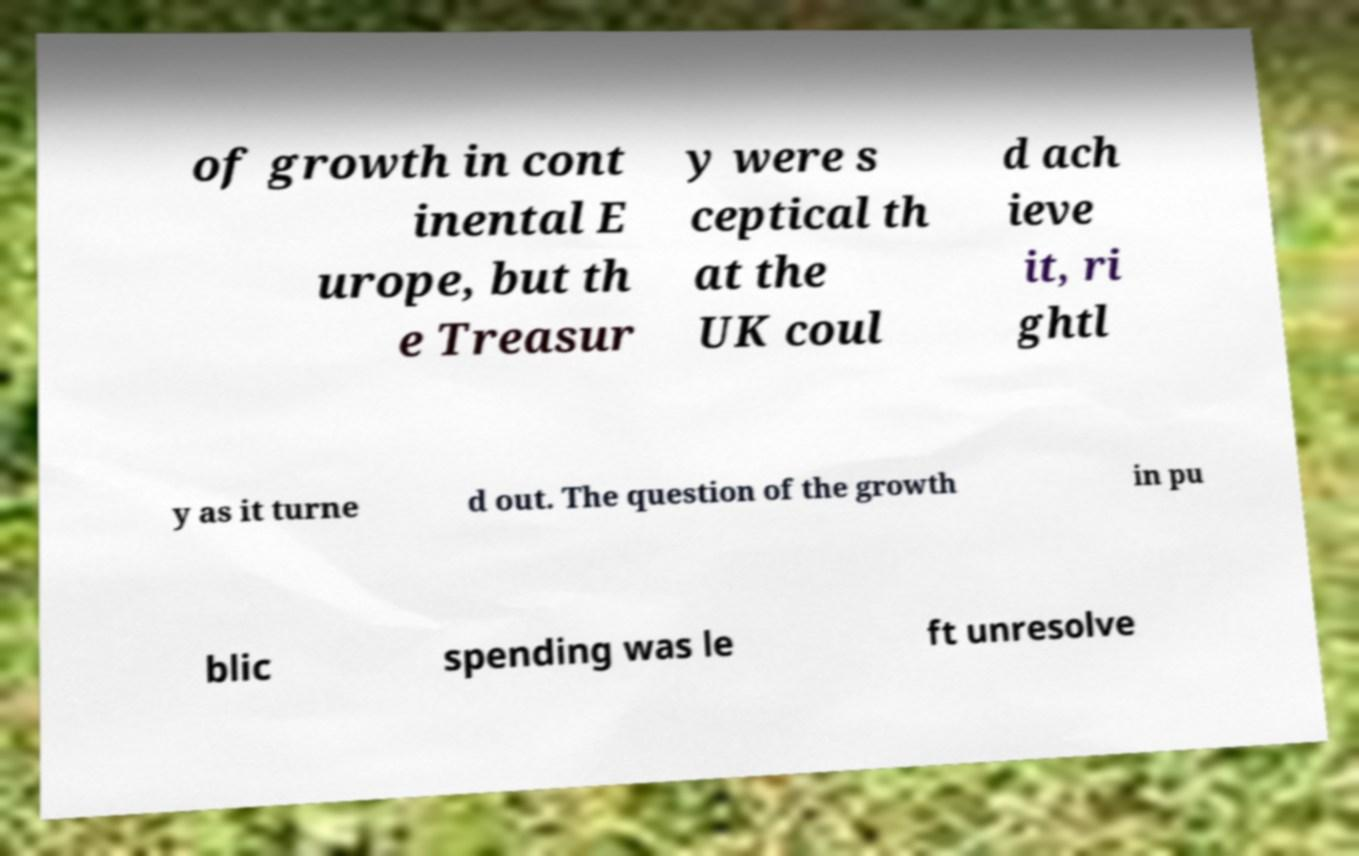Please read and relay the text visible in this image. What does it say? of growth in cont inental E urope, but th e Treasur y were s ceptical th at the UK coul d ach ieve it, ri ghtl y as it turne d out. The question of the growth in pu blic spending was le ft unresolve 